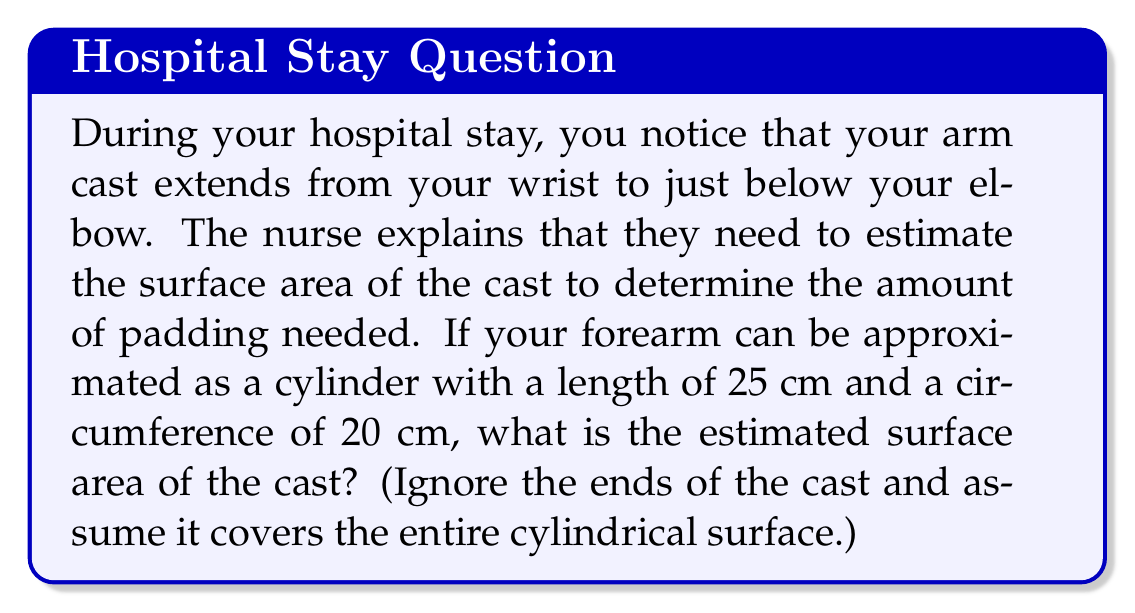Can you answer this question? To solve this problem, we'll follow these steps:

1) First, we need to recognize that the surface area of the cast is equivalent to the lateral surface area of a cylinder (excluding the circular ends).

2) The formula for the lateral surface area of a cylinder is:
   $$A = 2\pi rh$$
   where $A$ is the surface area, $r$ is the radius, and $h$ is the height (length) of the cylinder.

3) We're given the circumference and length, but we need the radius. We can find this using the circumference formula:
   $$C = 2\pi r$$
   where $C$ is the circumference.

4) Rearranging this formula to solve for $r$:
   $$r = \frac{C}{2\pi}$$

5) Substituting the given circumference:
   $$r = \frac{20 \text{ cm}}{2\pi} \approx 3.18 \text{ cm}$$

6) Now we can use the lateral surface area formula, substituting our values:
   $$A = 2\pi rh = 2\pi (3.18 \text{ cm})(25 \text{ cm})$$

7) Simplifying:
   $$A = 2\pi (79.5 \text{ cm}^2) \approx 499.36 \text{ cm}^2$$

Therefore, the estimated surface area of the cast is approximately 499.36 square centimeters.
Answer: $499.36 \text{ cm}^2$ 